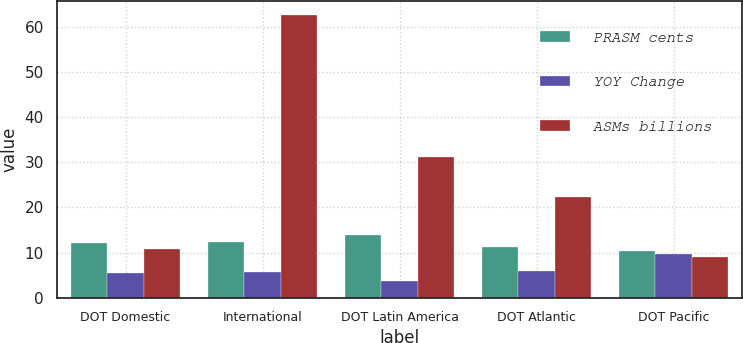Convert chart. <chart><loc_0><loc_0><loc_500><loc_500><stacked_bar_chart><ecel><fcel>DOT Domestic<fcel>International<fcel>DOT Latin America<fcel>DOT Atlantic<fcel>DOT Pacific<nl><fcel>PRASM cents<fcel>12.19<fcel>12.41<fcel>13.86<fcel>11.17<fcel>10.45<nl><fcel>YOY Change<fcel>5.5<fcel>5.7<fcel>3.8<fcel>5.9<fcel>9.6<nl><fcel>ASMs billions<fcel>10.81<fcel>62.7<fcel>31.3<fcel>22.3<fcel>9.1<nl></chart> 